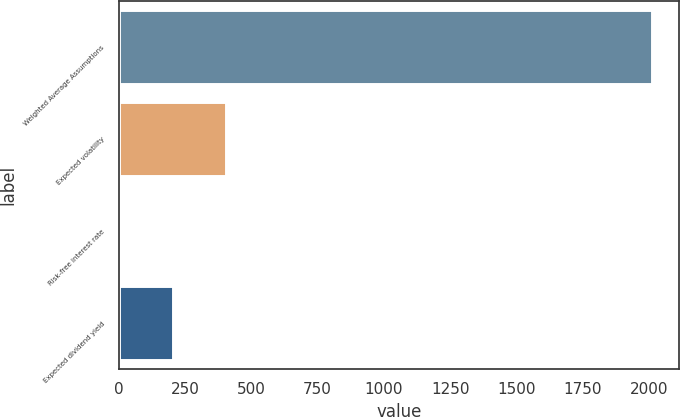Convert chart. <chart><loc_0><loc_0><loc_500><loc_500><bar_chart><fcel>Weighted Average Assumptions<fcel>Expected volatility<fcel>Risk-free interest rate<fcel>Expected dividend yield<nl><fcel>2012<fcel>403.4<fcel>1.24<fcel>202.32<nl></chart> 